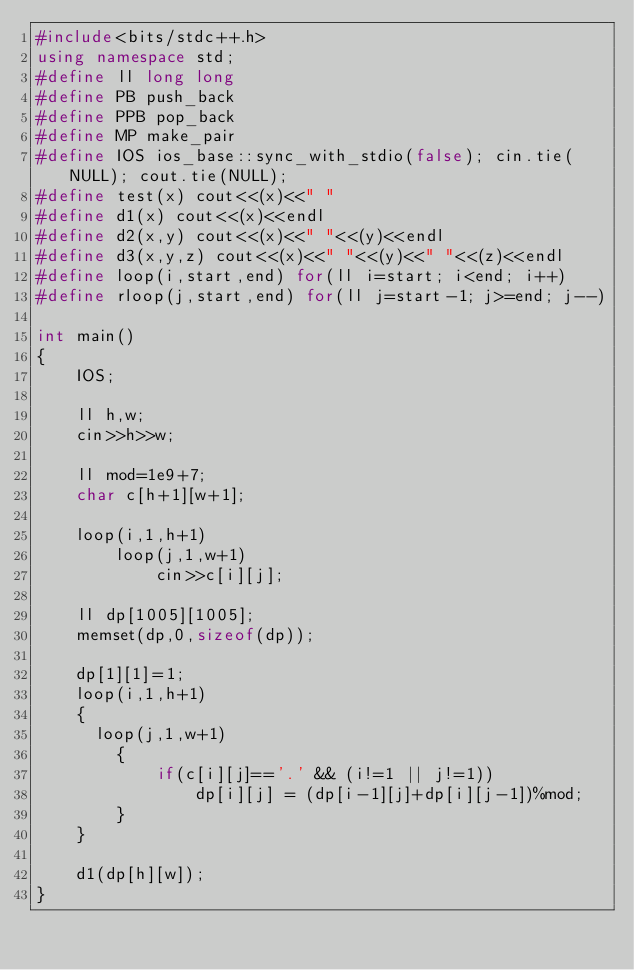<code> <loc_0><loc_0><loc_500><loc_500><_C++_>#include<bits/stdc++.h>
using namespace std;
#define ll long long
#define PB push_back
#define PPB pop_back
#define MP make_pair
#define IOS ios_base::sync_with_stdio(false); cin.tie(NULL); cout.tie(NULL);
#define test(x) cout<<(x)<<" "
#define d1(x) cout<<(x)<<endl
#define d2(x,y) cout<<(x)<<" "<<(y)<<endl
#define d3(x,y,z) cout<<(x)<<" "<<(y)<<" "<<(z)<<endl
#define loop(i,start,end) for(ll i=start; i<end; i++)
#define rloop(j,start,end) for(ll j=start-1; j>=end; j--)

int main()
{   
    IOS;

    ll h,w;
    cin>>h>>w;
	
  	ll mod=1e9+7;
    char c[h+1][w+1];
  
    loop(i,1,h+1)
        loop(j,1,w+1)
            cin>>c[i][j];

    ll dp[1005][1005];
    memset(dp,0,sizeof(dp));
	
  	dp[1][1]=1;
    loop(i,1,h+1)
    {
      loop(j,1,w+1)
        {
            if(c[i][j]=='.' && (i!=1 || j!=1))
                dp[i][j] = (dp[i-1][j]+dp[i][j-1])%mod;
        }
    }

    d1(dp[h][w]);
}</code> 